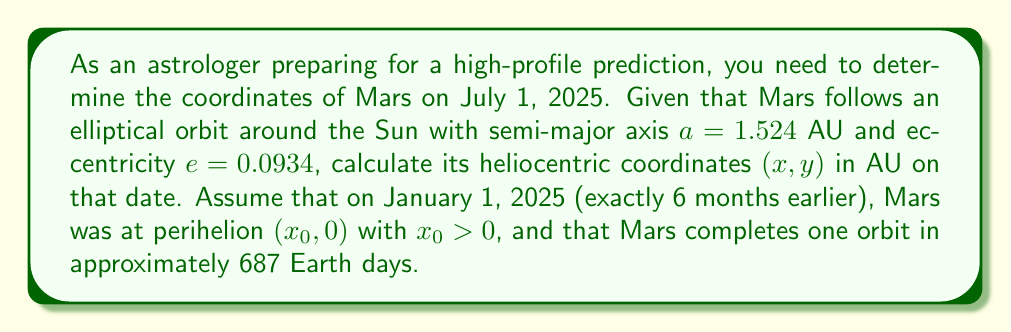What is the answer to this math problem? To solve this problem, we'll follow these steps:

1) First, let's calculate the position of Mars at perihelion:
   At perihelion, $r = a(1-e)$
   $x_0 = a(1-e) = 1.524(1-0.0934) = 1.3816$ AU

2) Now, we need to determine how much of its orbit Mars has completed in 6 months:
   Time for one orbit = 687 days
   Time elapsed = 181 days (approximate number of days in 6 months)
   Fraction of orbit completed = $\frac{181}{687} = 0.2635$

3) This fraction corresponds to an angle in the orbit. Let's call this angle $\theta$:
   $\theta = 0.2635 \times 2\pi = 1.6556$ radians

4) Now we can use the parametric equations for an ellipse to find the coordinates:
   $x = a(\cos E - e)$
   $y = a\sqrt{1-e^2}\sin E$

   Where $E$ is the eccentric anomaly, related to $\theta$ (the true anomaly) by:
   $\cos \theta = \frac{\cos E - e}{1 - e\cos E}$

5) We need to solve this equation for $E$. This typically requires numerical methods, but for this problem, we can approximate $E \approx \theta = 1.6556$

6) Now we can calculate $x$ and $y$:
   $x = 1.524(\cos 1.6556 - 0.0934) = 0.4052$ AU
   $y = 1.524\sqrt{1-0.0934^2}\sin 1.6556 = 1.4656$ AU

Therefore, the coordinates of Mars on July 1, 2025 will be approximately (0.4052, 1.4656) AU.
Answer: (0.4052, 1.4656) AU 